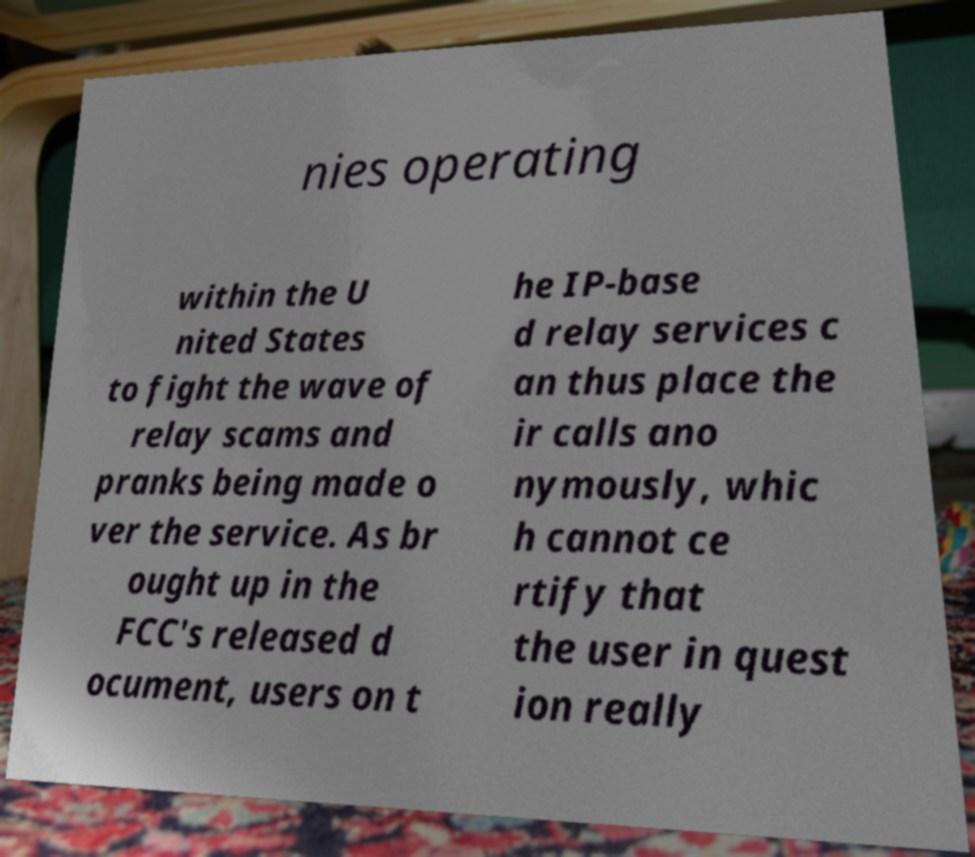I need the written content from this picture converted into text. Can you do that? nies operating within the U nited States to fight the wave of relay scams and pranks being made o ver the service. As br ought up in the FCC's released d ocument, users on t he IP-base d relay services c an thus place the ir calls ano nymously, whic h cannot ce rtify that the user in quest ion really 